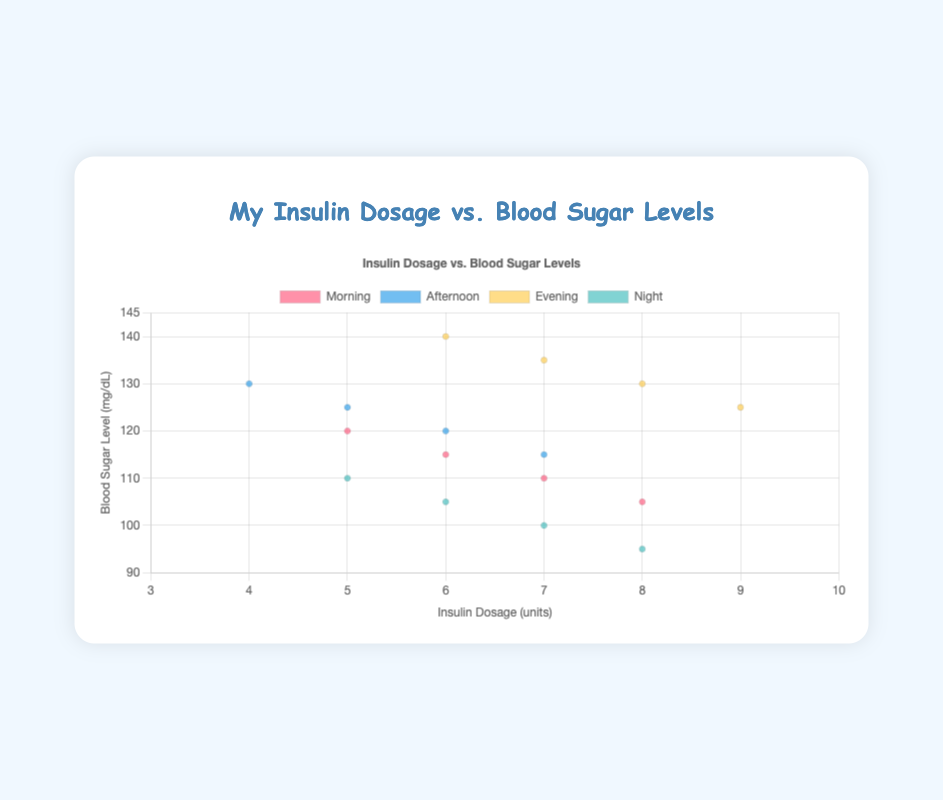How many data points are there in the Morning dataset? To find the number of data points, we look at the figure and count all the points labeled under 'Morning'. There are 4 data points shown in the Morning group.
Answer: 4 What is the highest blood sugar level recorded in the Evening? To find the highest blood sugar level in the Evening group, we look at all the 'Evening' points and identify the highest y-value. The highest blood sugar level for Evening is 140 mg/dL.
Answer: 140 What time of day shows the steepest decrease in blood sugar level with an increase in insulin dosage? To determine which time of day has the steepest decrease, we compare the slopes formed by the points for each time of day. The slope in the Morning shows a steep linear decrease, which can be visually identified by the sharply descending line.
Answer: Morning Is the blood sugar level distribution wider in the Morning or at Night? To find this out, we compare the range of blood sugar levels in the Morning and Night groups. The range for Morning is 105 mg/dL to 120 mg/dL (a span of 15), while the range for Night is 95 mg/dL to 110 mg/dL (also a span of 15). Both distributions are the same width.
Answer: Both are equal What is the average insulin dosage for the Afternoon group? To calculate the average insulin dosage for the Afternoon group, sum the insulin dosages and divide by the number of points: (4 + 5 + 6 + 7) / 4 = 22 / 4 = 5.5 units.
Answer: 5.5 units Which time of day shows the highest variation in blood sugar levels? To find the highest variation, compare the range of y-values (blood sugar levels) within each group visually. The Evening group shows the widest spread from 125 to 140 mg/dL, indicating the highest variation.
Answer: Evening Do all time-of-day groups show a decrease in blood sugar levels with increased insulin dosage? By observing each group in the scatter plot, all groups (Morning, Afternoon, Evening, and Night) show a declining trend in blood sugar levels as insulin dosage increases.
Answer: Yes Which group has the lowest insulin dosage point with the highest blood sugar level? We need to identify the group with the smallest insulin dosage and the highest corresponding blood sugar level. The Afternoon group has an insulin dosage of 4 units and a blood sugar level of 130 mg/dL, which fits the criteria.
Answer: Afternoon What is the median blood sugar level for the Night group? To find the median, we arrange the blood sugar levels of the Night group in ascending order: 95, 100, 105, 110. With 4 data points, the median is the average of the 2nd and 3rd values: (100 + 105) / 2 = 102.5 mg/dL.
Answer: 102.5 mg/dL 